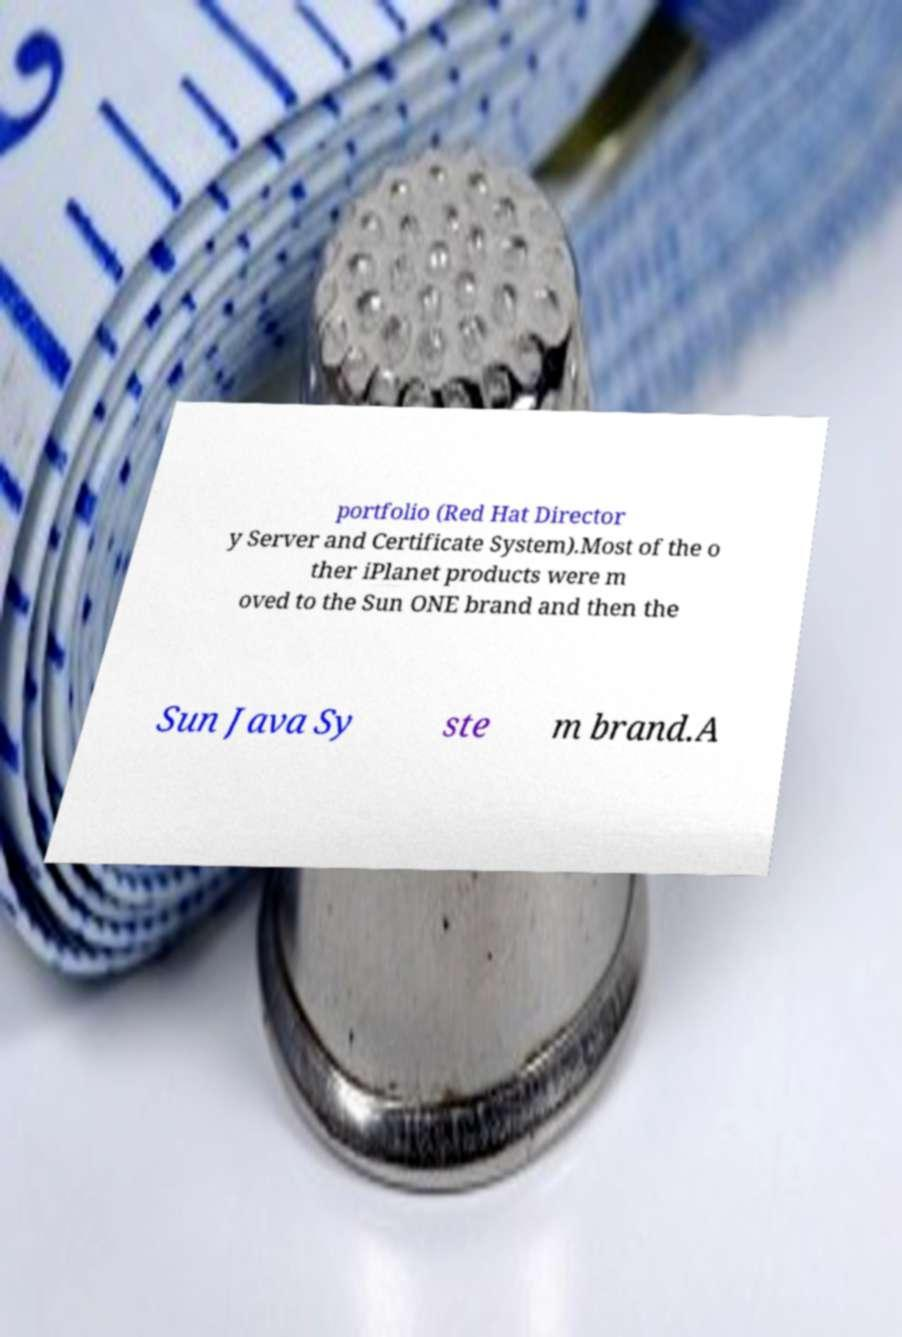I need the written content from this picture converted into text. Can you do that? portfolio (Red Hat Director y Server and Certificate System).Most of the o ther iPlanet products were m oved to the Sun ONE brand and then the Sun Java Sy ste m brand.A 